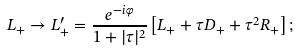Convert formula to latex. <formula><loc_0><loc_0><loc_500><loc_500>L _ { + } \rightarrow L _ { + } ^ { \prime } = \frac { e ^ { - i \varphi } } { 1 + | \tau | ^ { 2 } } \left [ L _ { + } + \tau D _ { + } + \tau ^ { 2 } R _ { + } \right ] ;</formula> 